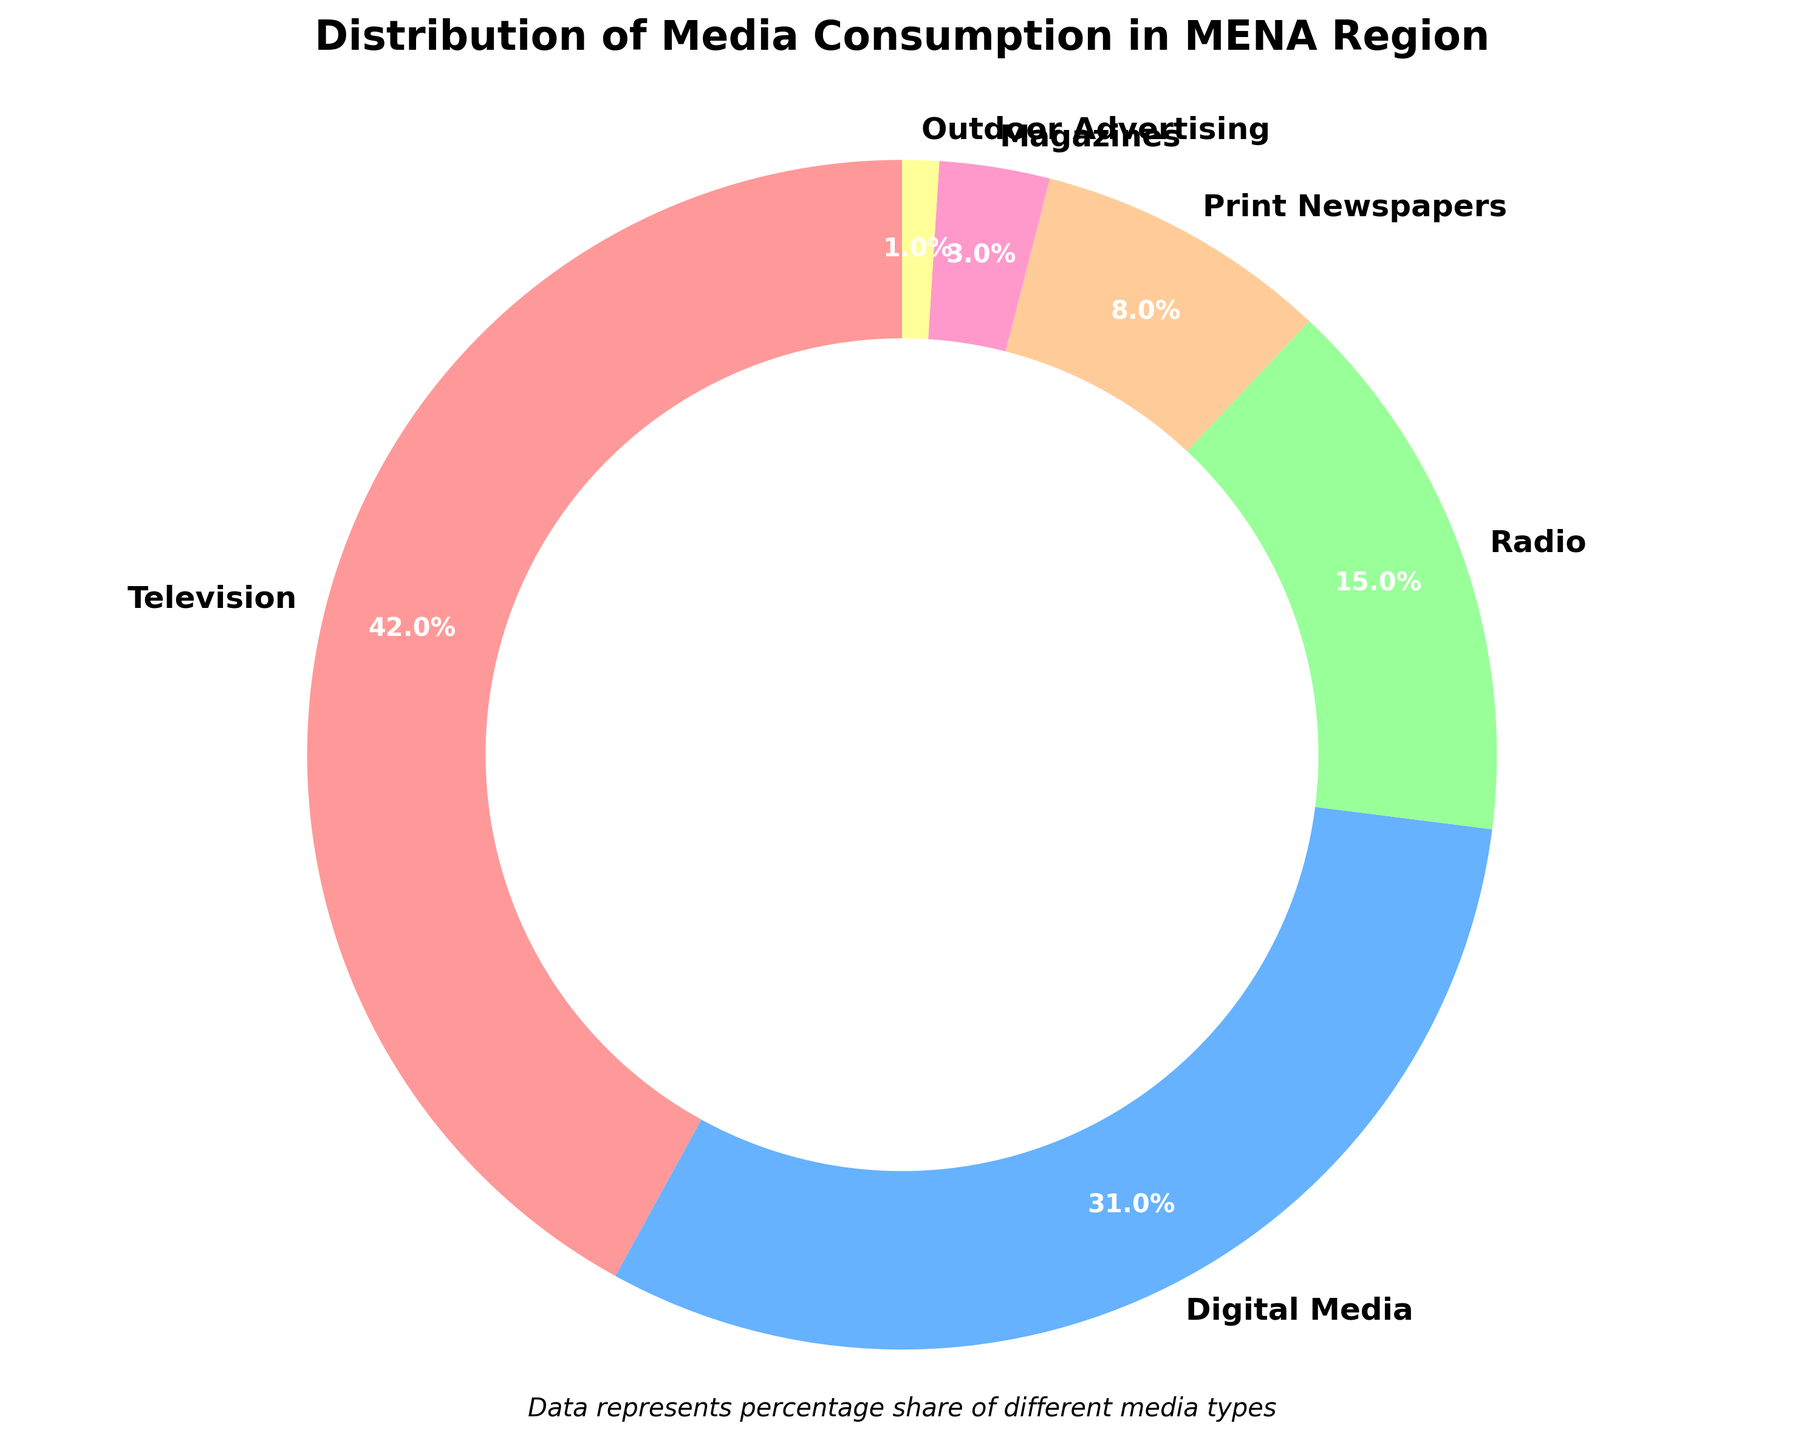What percentage of media consumption is accounted for by Television and Digital Media combined? To find the combined percentage of Television and Digital Media, add their individual percentages: 42% (Television) + 31% (Digital Media) = 73%.
Answer: 73% How does the percentage of Radio consumption compare to Print Newspapers? To compare Radio and Print Newspapers, look at their percentages: Radio is 15% and Print Newspapers is 8%. Thus, Radio consumption is higher than Print Newspapers.
Answer: Radio is higher What is the smallest segment in the media consumption distribution? The smallest segment can be identified by finding the media type with the smallest percentage. Outdoor Advertising is 1%, which is the smallest.
Answer: Outdoor Advertising Which media type contributes to almost half of the total media consumption? Identify the media type with a percentage closest to 50%. Television has 42%, which is almost half of the total media consumption.
Answer: Television By how much does the percentage of Digital Media exceed that of Magazines? To find the difference between Digital Media and Magazines, subtract the percentage of Magazines from Digital Media: 31% (Digital Media) - 3% (Magazines) = 28%.
Answer: 28% What is the total percentage of media consumption accounted for by Print Newspapers and Magazines? Add the percentages of Print Newspapers and Magazines: 8% (Print Newspapers) + 3% (Magazines) = 11%.
Answer: 11% Are there any media types with a percentage of consumption less than 5%? Identify media types with a percentage below 5%. Magazines (3%) and Outdoor Advertising (1%) both fall into this category.
Answer: Yes Which media type forms the largest segment of media consumption? Identify the segment with the highest percentage. Television has the largest percentage at 42%.
Answer: Television Compare the sum of Radio and Print Newspapers consumption with Digital Media. Is it higher or lower? First, sum the percentages of Radio and Print Newspapers: 15% (Radio) + 8% (Print Newspapers) = 23%. Compare that to Digital Media's 31%. 23% is lower than 31%.
Answer: Lower 